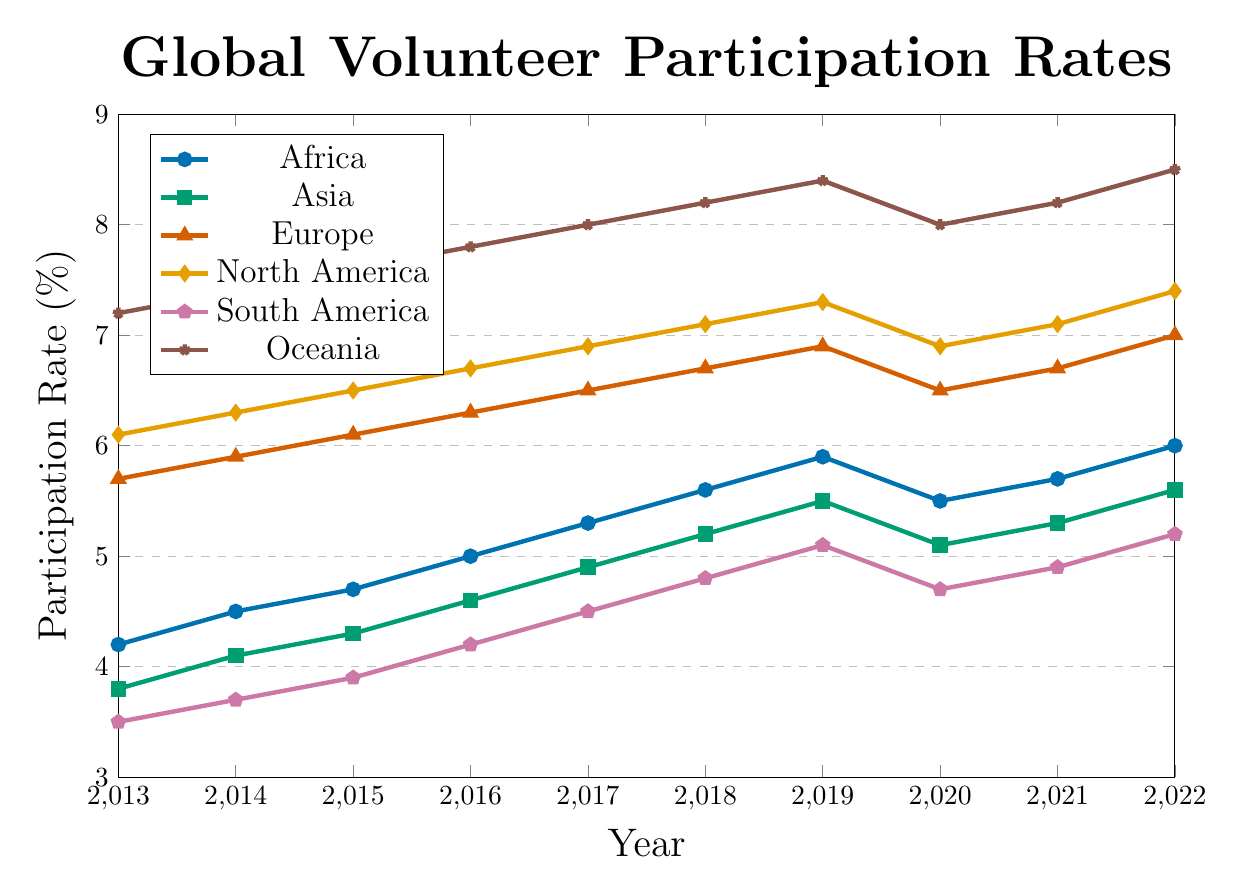What was the participation rate in Africa in 2016? Locate the point for Africa in 2016 on the x-axis and read the corresponding y-axis value. It's 5.0%.
Answer: 5.0% Which continent had the highest participation rate in 2022? Look at the y-axis values for all continents in 2022. Oceania has the highest rate at 8.5%.
Answer: Oceania Between which years did Europe see the greatest increase in participation rates? Calculate the differences year-by-year for Europe. The greatest increase is from 2021 (6.7%) to 2022 (7.0%), which is 0.3%.
Answer: 2021-2022 Compare the participation rates of North America and South America in 2020. Which continent had a higher rate and by how much? North America in 2020 was 6.9%, and South America was 4.7%. 6.9% - 4.7% = 2.2%. North America had a higher rate by 2.2%.
Answer: North America by 2.2% What was the average participation rate in Asia from 2020 to 2022? Sum the participation rates from 2020, 2021, and 2022 for Asia: 5.1% + 5.3% + 5.6% = 16%. Divide by 3: 16% / 3 ≈ 5.33%.
Answer: 5.33% Which continent showed the most continuous growth from 2013 to 2019? Check the general upward trend from 2013 to 2019. Oceania shows a continuous increase every year from 7.2% to 8.4%.
Answer: Oceania What is the median participation rate for South America from 2013 to 2022? List the rates: 3.5, 3.7, 3.9, 4.2, 4.5, 4.8, 5.1, 4.7, 4.9, 5.2. The middle values are 4.5 and 4.7, so the median is (4.5 + 4.7) / 2 = 4.6%.
Answer: 4.6% Identify the year with the smallest difference in participation rates between Africa and Asia. What is this difference? Calculate the differences year-by-year: 2013 (0.4), 2014 (0.4), 2015 (0.4), 2016 (0.4), 2017 (0.4), 2018 (0.4), 2019 (0.4), 2020 (0.4), 2021 (0.4), 2022 (0.4). The smallest difference is consistent at 0.4% every year.
Answer: 2013-2022, 0.4% 